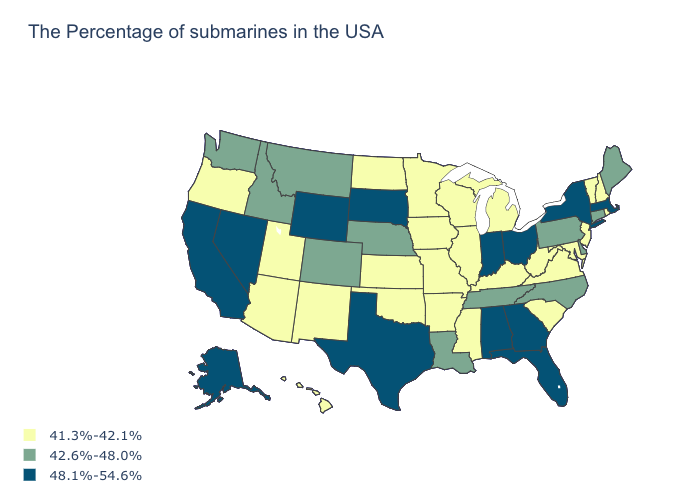What is the lowest value in the USA?
Short answer required. 41.3%-42.1%. Does Massachusetts have the highest value in the USA?
Concise answer only. Yes. Which states have the lowest value in the Northeast?
Keep it brief. Rhode Island, New Hampshire, Vermont, New Jersey. Does Mississippi have the same value as Maryland?
Write a very short answer. Yes. Does Colorado have the lowest value in the West?
Keep it brief. No. What is the value of Montana?
Quick response, please. 42.6%-48.0%. Name the states that have a value in the range 48.1%-54.6%?
Answer briefly. Massachusetts, New York, Ohio, Florida, Georgia, Indiana, Alabama, Texas, South Dakota, Wyoming, Nevada, California, Alaska. What is the value of Kansas?
Answer briefly. 41.3%-42.1%. What is the lowest value in states that border Arizona?
Write a very short answer. 41.3%-42.1%. What is the lowest value in the USA?
Concise answer only. 41.3%-42.1%. Does Oklahoma have a lower value than Massachusetts?
Concise answer only. Yes. Name the states that have a value in the range 42.6%-48.0%?
Short answer required. Maine, Connecticut, Delaware, Pennsylvania, North Carolina, Tennessee, Louisiana, Nebraska, Colorado, Montana, Idaho, Washington. What is the value of North Carolina?
Keep it brief. 42.6%-48.0%. What is the value of Maine?
Quick response, please. 42.6%-48.0%. 